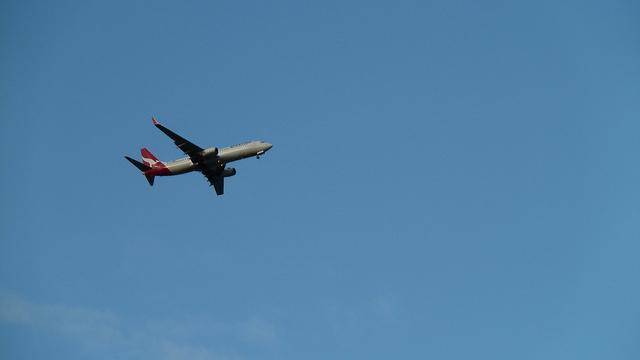Are these commercial airlines?
Short answer required. Yes. What kind of plane is this?
Be succinct. Jet. Is the plane landing?
Short answer required. No. Is the plane surrounded by clouds?
Answer briefly. No. What is the status of the landing gear?
Keep it brief. Up. Is that an airplane flying in the sky?
Give a very brief answer. Yes. Is this a  plane from the Blue Angels?
Concise answer only. No. Do you see clouds?
Keep it brief. No. Is the airplane blowing smoke?
Keep it brief. No. How many engines on the wings?
Write a very short answer. 2. 